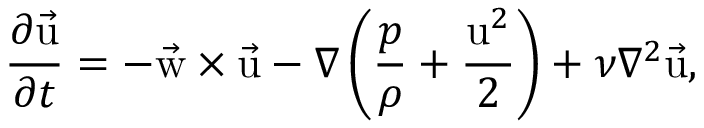<formula> <loc_0><loc_0><loc_500><loc_500>{ \frac { \partial \vec { u } } { \partial t } } = - \vec { w } \times \vec { u } - \nabla \left ( { \frac { p } { \rho } } + { \frac { u ^ { 2 } } { 2 } } \right ) + \nu \nabla ^ { 2 } \vec { u } ,</formula> 